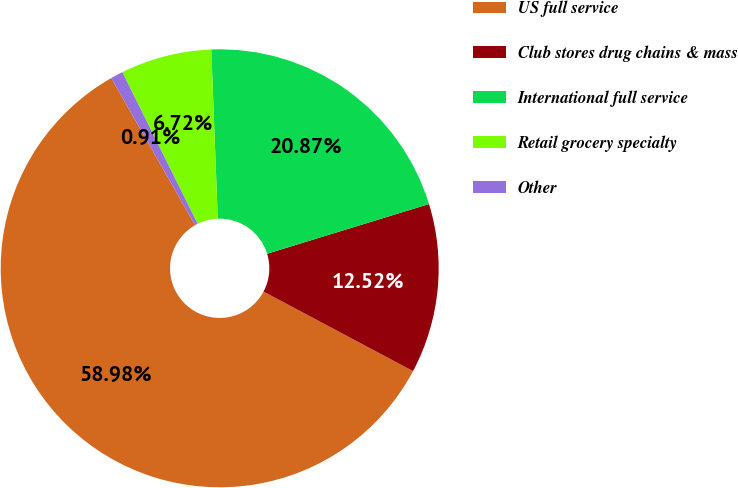Convert chart. <chart><loc_0><loc_0><loc_500><loc_500><pie_chart><fcel>US full service<fcel>Club stores drug chains & mass<fcel>International full service<fcel>Retail grocery specialty<fcel>Other<nl><fcel>58.98%<fcel>12.52%<fcel>20.87%<fcel>6.72%<fcel>0.91%<nl></chart> 